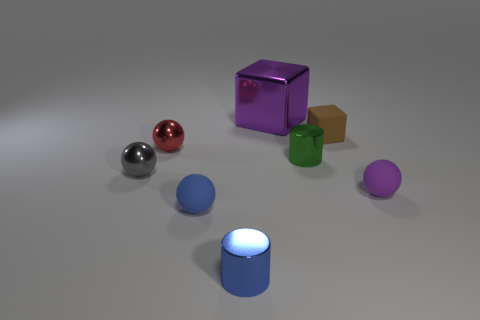Subtract all cyan spheres. Subtract all cyan cylinders. How many spheres are left? 4 Add 1 small blue matte cylinders. How many objects exist? 9 Subtract all cubes. How many objects are left? 6 Add 1 purple rubber balls. How many purple rubber balls exist? 2 Subtract 0 yellow spheres. How many objects are left? 8 Subtract all green cylinders. Subtract all tiny things. How many objects are left? 0 Add 6 green metallic cylinders. How many green metallic cylinders are left? 7 